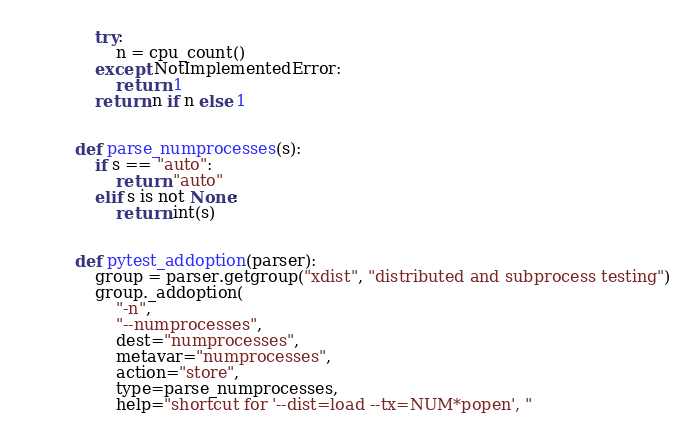<code> <loc_0><loc_0><loc_500><loc_500><_Python_>    try:
        n = cpu_count()
    except NotImplementedError:
        return 1
    return n if n else 1


def parse_numprocesses(s):
    if s == "auto":
        return "auto"
    elif s is not None:
        return int(s)


def pytest_addoption(parser):
    group = parser.getgroup("xdist", "distributed and subprocess testing")
    group._addoption(
        "-n",
        "--numprocesses",
        dest="numprocesses",
        metavar="numprocesses",
        action="store",
        type=parse_numprocesses,
        help="shortcut for '--dist=load --tx=NUM*popen', "</code> 